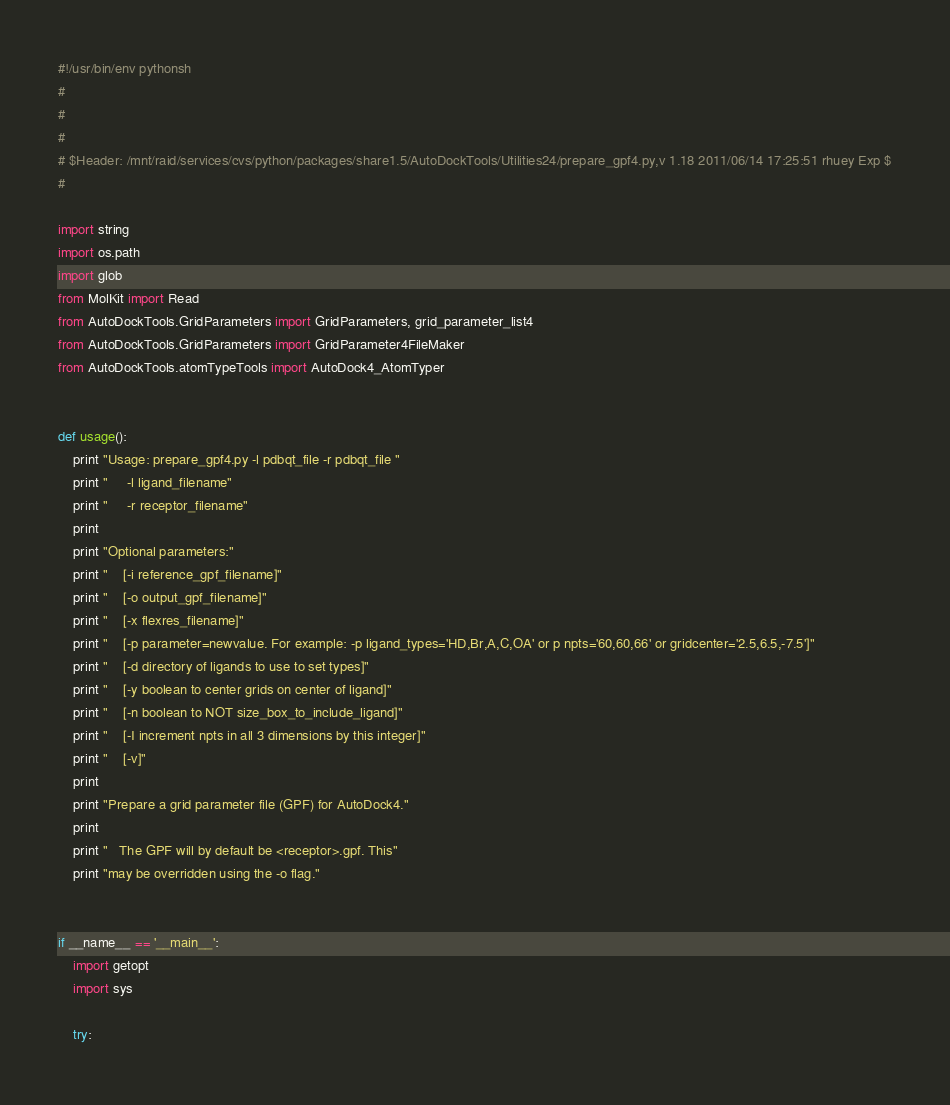Convert code to text. <code><loc_0><loc_0><loc_500><loc_500><_Python_>#!/usr/bin/env pythonsh
#
# 
#
# $Header: /mnt/raid/services/cvs/python/packages/share1.5/AutoDockTools/Utilities24/prepare_gpf4.py,v 1.18 2011/06/14 17:25:51 rhuey Exp $
#

import string
import os.path
import glob
from MolKit import Read
from AutoDockTools.GridParameters import GridParameters, grid_parameter_list4
from AutoDockTools.GridParameters import GridParameter4FileMaker
from AutoDockTools.atomTypeTools import AutoDock4_AtomTyper


def usage():
    print "Usage: prepare_gpf4.py -l pdbqt_file -r pdbqt_file "
    print "     -l ligand_filename"
    print "     -r receptor_filename"
    print
    print "Optional parameters:"
    print "    [-i reference_gpf_filename]"
    print "    [-o output_gpf_filename]"
    print "    [-x flexres_filename]"
    print "    [-p parameter=newvalue. For example: -p ligand_types='HD,Br,A,C,OA' or p npts='60,60,66' or gridcenter='2.5,6.5,-7.5']"
    print "    [-d directory of ligands to use to set types]"
    print "    [-y boolean to center grids on center of ligand]"
    print "    [-n boolean to NOT size_box_to_include_ligand]"
    print "    [-I increment npts in all 3 dimensions by this integer]"
    print "    [-v]"
    print
    print "Prepare a grid parameter file (GPF) for AutoDock4."
    print
    print "   The GPF will by default be <receptor>.gpf. This"
    print "may be overridden using the -o flag."

    
if __name__ == '__main__':
    import getopt
    import sys

    try:</code> 